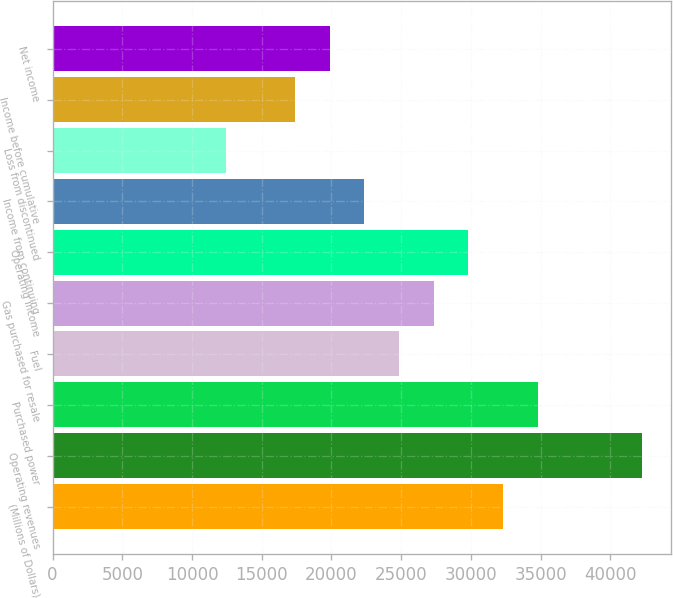Convert chart to OTSL. <chart><loc_0><loc_0><loc_500><loc_500><bar_chart><fcel>(Millions of Dollars)<fcel>Operating revenues<fcel>Purchased power<fcel>Fuel<fcel>Gas purchased for resale<fcel>Operating income<fcel>Income from continuing<fcel>Loss from discontinued<fcel>Income before cumulative<fcel>Net income<nl><fcel>32305<fcel>42245<fcel>34790<fcel>24850<fcel>27335<fcel>29820<fcel>22365<fcel>12425<fcel>17395<fcel>19880<nl></chart> 